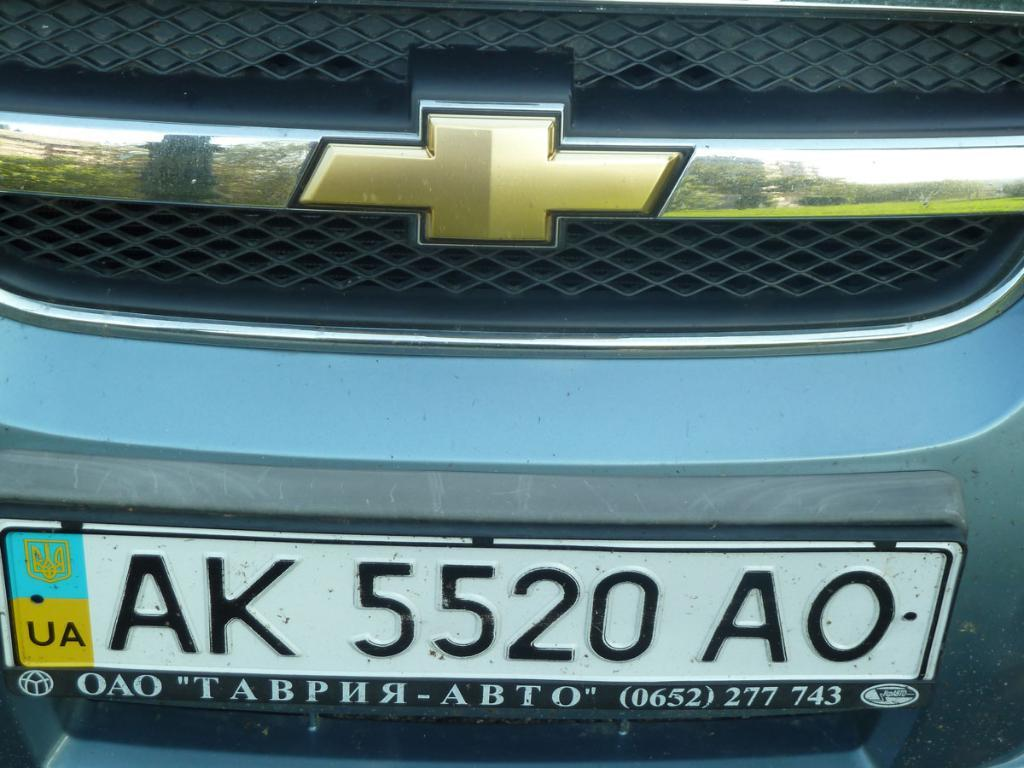Provide a one-sentence caption for the provided image. The front grill of an automobile with license plate number AK 5520 AO. 